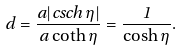<formula> <loc_0><loc_0><loc_500><loc_500>d = \frac { a | c s c h \, \eta | } { a \coth \eta } = \frac { 1 } { \cosh \eta } .</formula> 